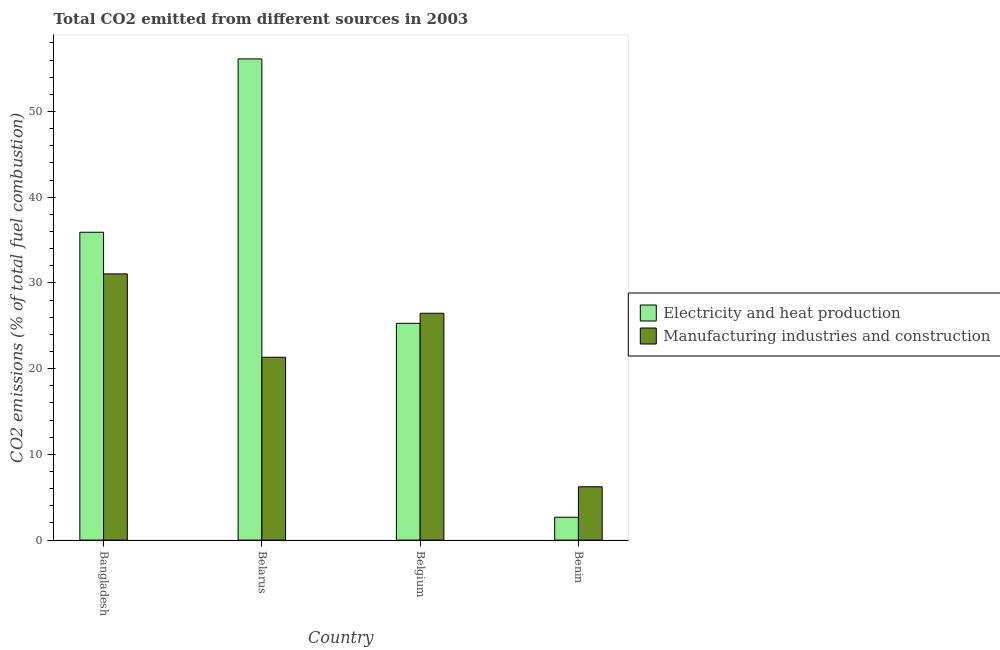How many groups of bars are there?
Give a very brief answer. 4. Are the number of bars per tick equal to the number of legend labels?
Offer a very short reply. Yes. How many bars are there on the 3rd tick from the left?
Make the answer very short. 2. How many bars are there on the 2nd tick from the right?
Make the answer very short. 2. What is the label of the 1st group of bars from the left?
Provide a short and direct response. Bangladesh. In how many cases, is the number of bars for a given country not equal to the number of legend labels?
Offer a very short reply. 0. What is the co2 emissions due to manufacturing industries in Belarus?
Your answer should be very brief. 21.34. Across all countries, what is the maximum co2 emissions due to manufacturing industries?
Your answer should be very brief. 31.06. Across all countries, what is the minimum co2 emissions due to manufacturing industries?
Ensure brevity in your answer.  6.22. In which country was the co2 emissions due to electricity and heat production minimum?
Your response must be concise. Benin. What is the total co2 emissions due to electricity and heat production in the graph?
Your response must be concise. 120.02. What is the difference between the co2 emissions due to manufacturing industries in Bangladesh and that in Belgium?
Keep it short and to the point. 4.59. What is the difference between the co2 emissions due to electricity and heat production in Bangladesh and the co2 emissions due to manufacturing industries in Belarus?
Make the answer very short. 14.58. What is the average co2 emissions due to electricity and heat production per country?
Keep it short and to the point. 30. What is the difference between the co2 emissions due to electricity and heat production and co2 emissions due to manufacturing industries in Bangladesh?
Your answer should be very brief. 4.86. In how many countries, is the co2 emissions due to manufacturing industries greater than 44 %?
Give a very brief answer. 0. What is the ratio of the co2 emissions due to electricity and heat production in Bangladesh to that in Belgium?
Ensure brevity in your answer.  1.42. What is the difference between the highest and the second highest co2 emissions due to manufacturing industries?
Make the answer very short. 4.59. What is the difference between the highest and the lowest co2 emissions due to manufacturing industries?
Your response must be concise. 24.84. In how many countries, is the co2 emissions due to manufacturing industries greater than the average co2 emissions due to manufacturing industries taken over all countries?
Offer a terse response. 3. Is the sum of the co2 emissions due to manufacturing industries in Bangladesh and Benin greater than the maximum co2 emissions due to electricity and heat production across all countries?
Provide a succinct answer. No. What does the 1st bar from the left in Bangladesh represents?
Offer a very short reply. Electricity and heat production. What does the 1st bar from the right in Bangladesh represents?
Make the answer very short. Manufacturing industries and construction. How many bars are there?
Keep it short and to the point. 8. What is the difference between two consecutive major ticks on the Y-axis?
Your answer should be compact. 10. Are the values on the major ticks of Y-axis written in scientific E-notation?
Give a very brief answer. No. Does the graph contain grids?
Your answer should be very brief. No. How are the legend labels stacked?
Your answer should be very brief. Vertical. What is the title of the graph?
Offer a very short reply. Total CO2 emitted from different sources in 2003. Does "Exports" appear as one of the legend labels in the graph?
Provide a short and direct response. No. What is the label or title of the X-axis?
Provide a succinct answer. Country. What is the label or title of the Y-axis?
Provide a short and direct response. CO2 emissions (% of total fuel combustion). What is the CO2 emissions (% of total fuel combustion) in Electricity and heat production in Bangladesh?
Ensure brevity in your answer.  35.92. What is the CO2 emissions (% of total fuel combustion) of Manufacturing industries and construction in Bangladesh?
Make the answer very short. 31.06. What is the CO2 emissions (% of total fuel combustion) of Electricity and heat production in Belarus?
Ensure brevity in your answer.  56.14. What is the CO2 emissions (% of total fuel combustion) of Manufacturing industries and construction in Belarus?
Give a very brief answer. 21.34. What is the CO2 emissions (% of total fuel combustion) in Electricity and heat production in Belgium?
Offer a very short reply. 25.29. What is the CO2 emissions (% of total fuel combustion) of Manufacturing industries and construction in Belgium?
Your answer should be compact. 26.46. What is the CO2 emissions (% of total fuel combustion) of Electricity and heat production in Benin?
Offer a very short reply. 2.67. What is the CO2 emissions (% of total fuel combustion) of Manufacturing industries and construction in Benin?
Provide a succinct answer. 6.22. Across all countries, what is the maximum CO2 emissions (% of total fuel combustion) of Electricity and heat production?
Your answer should be very brief. 56.14. Across all countries, what is the maximum CO2 emissions (% of total fuel combustion) in Manufacturing industries and construction?
Offer a very short reply. 31.06. Across all countries, what is the minimum CO2 emissions (% of total fuel combustion) of Electricity and heat production?
Provide a succinct answer. 2.67. Across all countries, what is the minimum CO2 emissions (% of total fuel combustion) of Manufacturing industries and construction?
Your answer should be compact. 6.22. What is the total CO2 emissions (% of total fuel combustion) in Electricity and heat production in the graph?
Your answer should be compact. 120.02. What is the total CO2 emissions (% of total fuel combustion) in Manufacturing industries and construction in the graph?
Keep it short and to the point. 85.08. What is the difference between the CO2 emissions (% of total fuel combustion) of Electricity and heat production in Bangladesh and that in Belarus?
Your answer should be very brief. -20.22. What is the difference between the CO2 emissions (% of total fuel combustion) of Manufacturing industries and construction in Bangladesh and that in Belarus?
Ensure brevity in your answer.  9.72. What is the difference between the CO2 emissions (% of total fuel combustion) of Electricity and heat production in Bangladesh and that in Belgium?
Offer a terse response. 10.63. What is the difference between the CO2 emissions (% of total fuel combustion) of Manufacturing industries and construction in Bangladesh and that in Belgium?
Your answer should be very brief. 4.59. What is the difference between the CO2 emissions (% of total fuel combustion) in Electricity and heat production in Bangladesh and that in Benin?
Your answer should be compact. 33.25. What is the difference between the CO2 emissions (% of total fuel combustion) of Manufacturing industries and construction in Bangladesh and that in Benin?
Provide a succinct answer. 24.84. What is the difference between the CO2 emissions (% of total fuel combustion) in Electricity and heat production in Belarus and that in Belgium?
Your response must be concise. 30.85. What is the difference between the CO2 emissions (% of total fuel combustion) in Manufacturing industries and construction in Belarus and that in Belgium?
Your answer should be compact. -5.13. What is the difference between the CO2 emissions (% of total fuel combustion) of Electricity and heat production in Belarus and that in Benin?
Provide a short and direct response. 53.47. What is the difference between the CO2 emissions (% of total fuel combustion) of Manufacturing industries and construction in Belarus and that in Benin?
Your answer should be compact. 15.11. What is the difference between the CO2 emissions (% of total fuel combustion) in Electricity and heat production in Belgium and that in Benin?
Ensure brevity in your answer.  22.62. What is the difference between the CO2 emissions (% of total fuel combustion) of Manufacturing industries and construction in Belgium and that in Benin?
Your answer should be compact. 20.24. What is the difference between the CO2 emissions (% of total fuel combustion) in Electricity and heat production in Bangladesh and the CO2 emissions (% of total fuel combustion) in Manufacturing industries and construction in Belarus?
Keep it short and to the point. 14.58. What is the difference between the CO2 emissions (% of total fuel combustion) in Electricity and heat production in Bangladesh and the CO2 emissions (% of total fuel combustion) in Manufacturing industries and construction in Belgium?
Your answer should be compact. 9.45. What is the difference between the CO2 emissions (% of total fuel combustion) in Electricity and heat production in Bangladesh and the CO2 emissions (% of total fuel combustion) in Manufacturing industries and construction in Benin?
Offer a very short reply. 29.7. What is the difference between the CO2 emissions (% of total fuel combustion) of Electricity and heat production in Belarus and the CO2 emissions (% of total fuel combustion) of Manufacturing industries and construction in Belgium?
Give a very brief answer. 29.68. What is the difference between the CO2 emissions (% of total fuel combustion) of Electricity and heat production in Belarus and the CO2 emissions (% of total fuel combustion) of Manufacturing industries and construction in Benin?
Offer a terse response. 49.92. What is the difference between the CO2 emissions (% of total fuel combustion) in Electricity and heat production in Belgium and the CO2 emissions (% of total fuel combustion) in Manufacturing industries and construction in Benin?
Provide a succinct answer. 19.07. What is the average CO2 emissions (% of total fuel combustion) of Electricity and heat production per country?
Ensure brevity in your answer.  30. What is the average CO2 emissions (% of total fuel combustion) of Manufacturing industries and construction per country?
Make the answer very short. 21.27. What is the difference between the CO2 emissions (% of total fuel combustion) of Electricity and heat production and CO2 emissions (% of total fuel combustion) of Manufacturing industries and construction in Bangladesh?
Your response must be concise. 4.86. What is the difference between the CO2 emissions (% of total fuel combustion) of Electricity and heat production and CO2 emissions (% of total fuel combustion) of Manufacturing industries and construction in Belarus?
Provide a succinct answer. 34.8. What is the difference between the CO2 emissions (% of total fuel combustion) in Electricity and heat production and CO2 emissions (% of total fuel combustion) in Manufacturing industries and construction in Belgium?
Your response must be concise. -1.17. What is the difference between the CO2 emissions (% of total fuel combustion) in Electricity and heat production and CO2 emissions (% of total fuel combustion) in Manufacturing industries and construction in Benin?
Ensure brevity in your answer.  -3.56. What is the ratio of the CO2 emissions (% of total fuel combustion) of Electricity and heat production in Bangladesh to that in Belarus?
Ensure brevity in your answer.  0.64. What is the ratio of the CO2 emissions (% of total fuel combustion) in Manufacturing industries and construction in Bangladesh to that in Belarus?
Make the answer very short. 1.46. What is the ratio of the CO2 emissions (% of total fuel combustion) in Electricity and heat production in Bangladesh to that in Belgium?
Provide a succinct answer. 1.42. What is the ratio of the CO2 emissions (% of total fuel combustion) in Manufacturing industries and construction in Bangladesh to that in Belgium?
Provide a succinct answer. 1.17. What is the ratio of the CO2 emissions (% of total fuel combustion) in Electricity and heat production in Bangladesh to that in Benin?
Give a very brief answer. 13.47. What is the ratio of the CO2 emissions (% of total fuel combustion) in Manufacturing industries and construction in Bangladesh to that in Benin?
Provide a short and direct response. 4.99. What is the ratio of the CO2 emissions (% of total fuel combustion) in Electricity and heat production in Belarus to that in Belgium?
Provide a short and direct response. 2.22. What is the ratio of the CO2 emissions (% of total fuel combustion) in Manufacturing industries and construction in Belarus to that in Belgium?
Keep it short and to the point. 0.81. What is the ratio of the CO2 emissions (% of total fuel combustion) in Electricity and heat production in Belarus to that in Benin?
Make the answer very short. 21.05. What is the ratio of the CO2 emissions (% of total fuel combustion) in Manufacturing industries and construction in Belarus to that in Benin?
Give a very brief answer. 3.43. What is the ratio of the CO2 emissions (% of total fuel combustion) of Electricity and heat production in Belgium to that in Benin?
Make the answer very short. 9.48. What is the ratio of the CO2 emissions (% of total fuel combustion) of Manufacturing industries and construction in Belgium to that in Benin?
Keep it short and to the point. 4.25. What is the difference between the highest and the second highest CO2 emissions (% of total fuel combustion) of Electricity and heat production?
Provide a short and direct response. 20.22. What is the difference between the highest and the second highest CO2 emissions (% of total fuel combustion) in Manufacturing industries and construction?
Provide a short and direct response. 4.59. What is the difference between the highest and the lowest CO2 emissions (% of total fuel combustion) of Electricity and heat production?
Make the answer very short. 53.47. What is the difference between the highest and the lowest CO2 emissions (% of total fuel combustion) in Manufacturing industries and construction?
Provide a succinct answer. 24.84. 